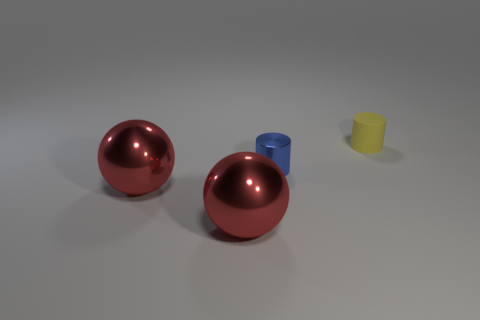Are there any other things of the same color as the tiny matte cylinder?
Ensure brevity in your answer.  No. Are there fewer metal spheres that are on the right side of the tiny yellow object than rubber objects?
Give a very brief answer. Yes. Is the number of large metallic spheres greater than the number of big cyan metal spheres?
Offer a terse response. Yes. Are there any large red spheres that are right of the cylinder that is behind the cylinder that is to the left of the small yellow rubber cylinder?
Your response must be concise. No. How many other objects are there of the same size as the yellow matte cylinder?
Provide a succinct answer. 1. There is a tiny yellow rubber cylinder; are there any tiny metallic objects behind it?
Offer a very short reply. No. Does the tiny metallic cylinder have the same color as the object that is right of the small blue thing?
Give a very brief answer. No. What color is the small object to the left of the cylinder that is behind the small object that is to the left of the yellow cylinder?
Your answer should be compact. Blue. Is there a big red object of the same shape as the tiny yellow thing?
Provide a succinct answer. No. The metal object that is the same size as the matte cylinder is what color?
Give a very brief answer. Blue. 